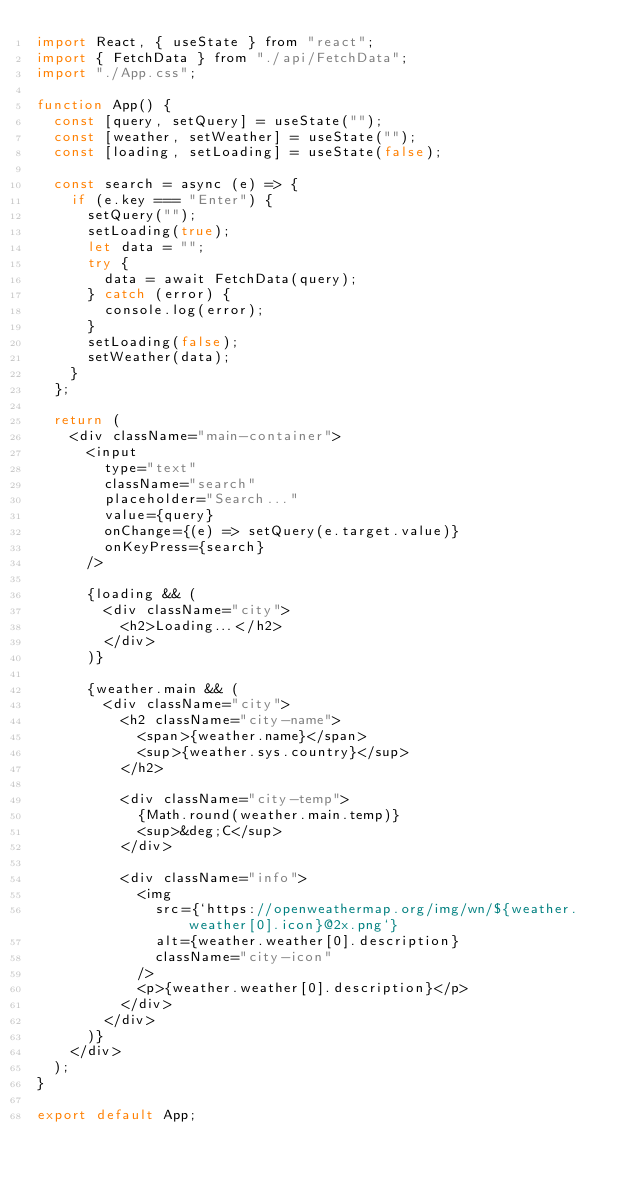Convert code to text. <code><loc_0><loc_0><loc_500><loc_500><_JavaScript_>import React, { useState } from "react";
import { FetchData } from "./api/FetchData";
import "./App.css";

function App() {
	const [query, setQuery] = useState("");
	const [weather, setWeather] = useState("");
	const [loading, setLoading] = useState(false);

	const search = async (e) => {
		if (e.key === "Enter") {
			setQuery("");
			setLoading(true);
			let data = "";
			try {
				data = await FetchData(query);
			} catch (error) {
				console.log(error);
			}
			setLoading(false);
			setWeather(data);
		}
	};

	return (
		<div className="main-container">
			<input
				type="text"
				className="search"
				placeholder="Search..."
				value={query}
				onChange={(e) => setQuery(e.target.value)}
				onKeyPress={search}
			/>

			{loading && (
				<div className="city">
					<h2>Loading...</h2>
				</div>
			)}

			{weather.main && (
				<div className="city">
					<h2 className="city-name">
						<span>{weather.name}</span>
						<sup>{weather.sys.country}</sup>
					</h2>

					<div className="city-temp">
						{Math.round(weather.main.temp)}
						<sup>&deg;C</sup>
					</div>

					<div className="info">
						<img
							src={`https://openweathermap.org/img/wn/${weather.weather[0].icon}@2x.png`}
							alt={weather.weather[0].description}
							className="city-icon"
						/>
						<p>{weather.weather[0].description}</p>
					</div>
				</div>
			)}
		</div>
	);
}

export default App;
</code> 